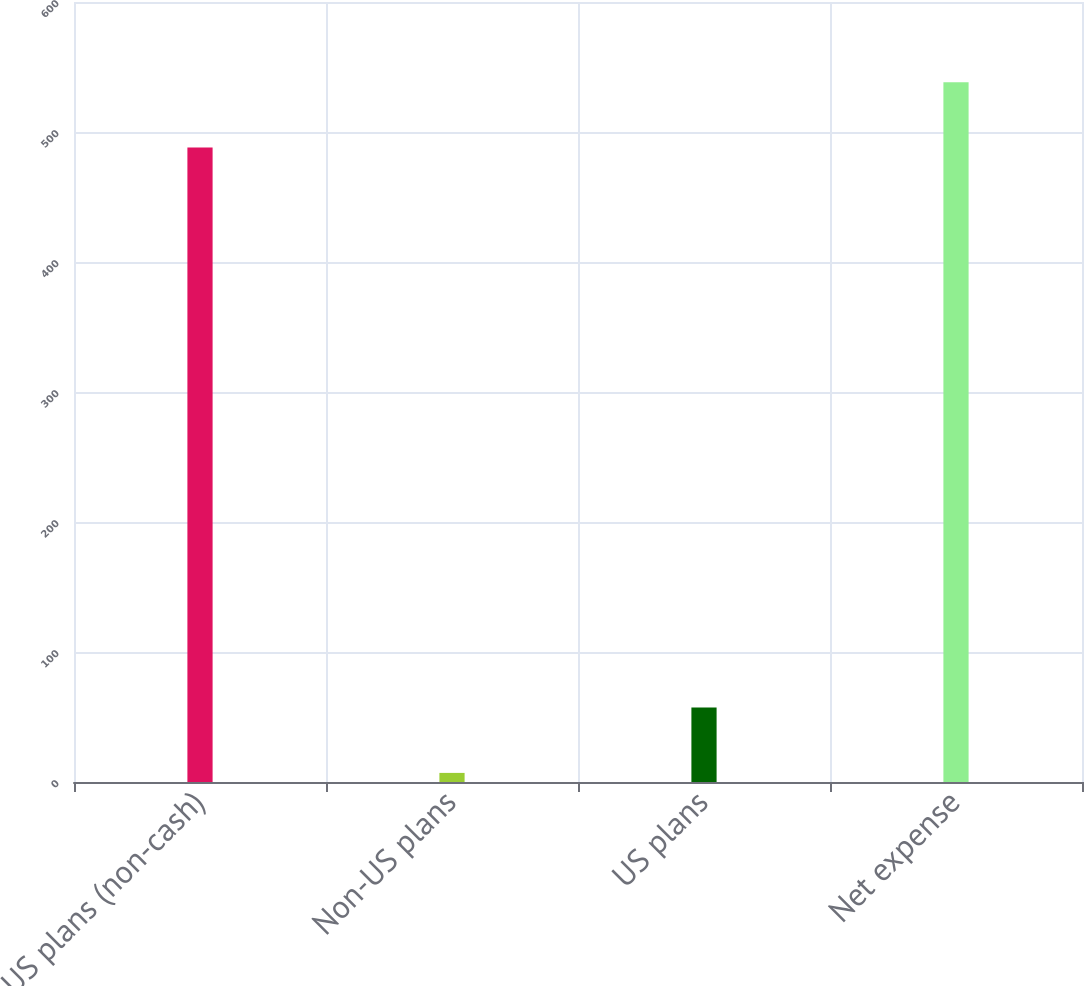Convert chart. <chart><loc_0><loc_0><loc_500><loc_500><bar_chart><fcel>US plans (non-cash)<fcel>Non-US plans<fcel>US plans<fcel>Net expense<nl><fcel>488<fcel>7<fcel>57.3<fcel>538.3<nl></chart> 